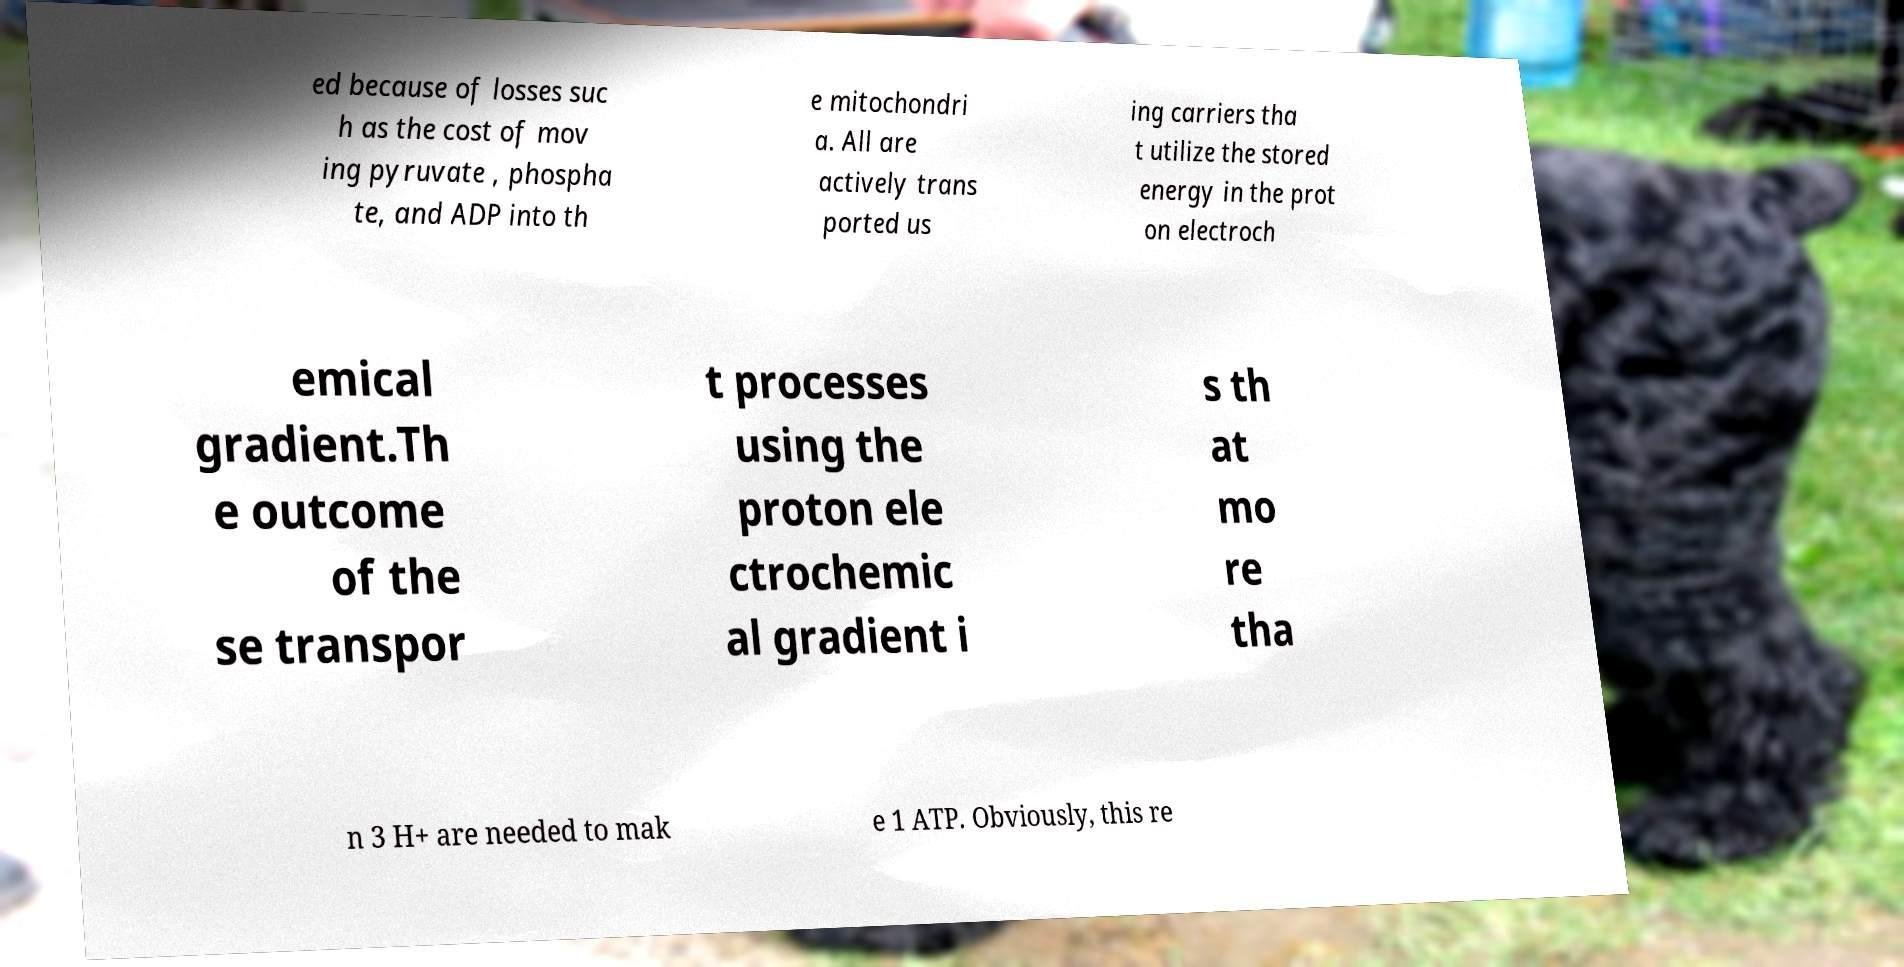What messages or text are displayed in this image? I need them in a readable, typed format. ed because of losses suc h as the cost of mov ing pyruvate , phospha te, and ADP into th e mitochondri a. All are actively trans ported us ing carriers tha t utilize the stored energy in the prot on electroch emical gradient.Th e outcome of the se transpor t processes using the proton ele ctrochemic al gradient i s th at mo re tha n 3 H+ are needed to mak e 1 ATP. Obviously, this re 